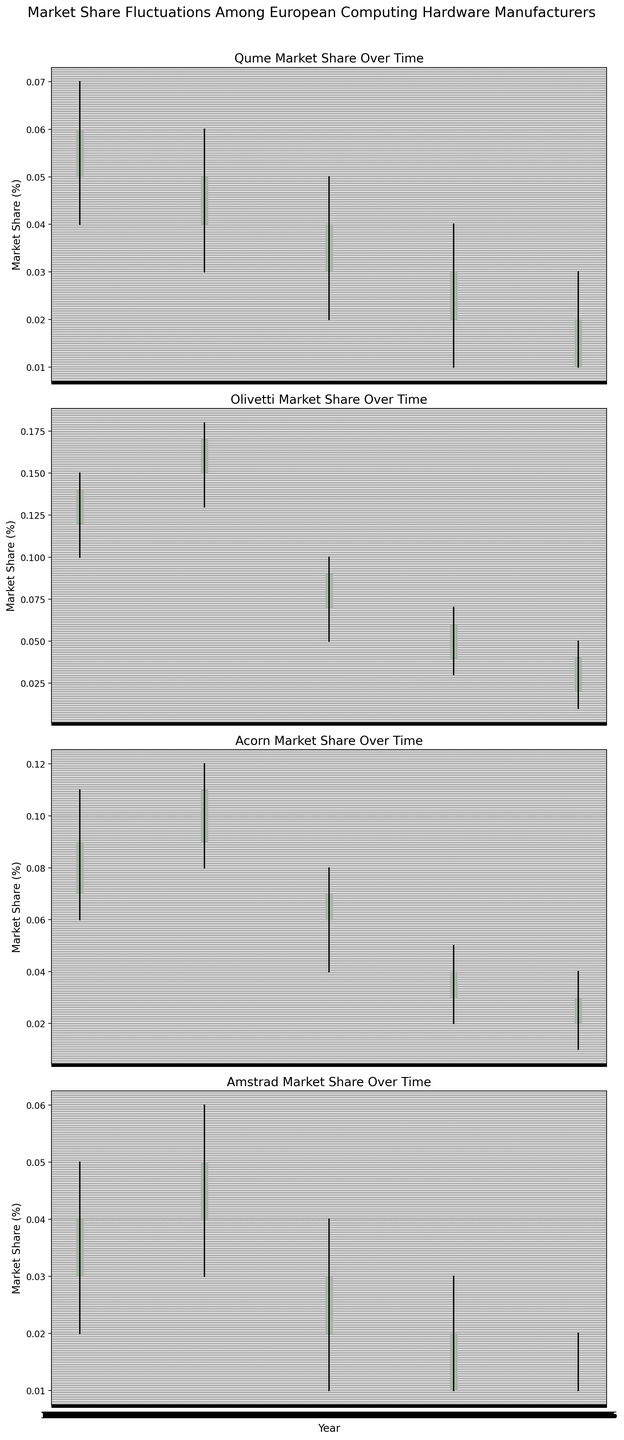Which company showed the highest market share in 1993? Look at the year 1993 across all subplots; observe Olivetti's candlestick, which has the highest market share value.
Answer: Olivetti What was the general trend for Amstrad's market share from 1983 to 2023? Observe the downward trend in the candlestick heights for Amstrad from 1983 to 2023, indicating a decline in market share over time.
Answer: Declining Which company had the smallest difference between its highest and lowest market share in 2023? For each company in 2023, calculate the differences between the high and low values: Qume (0.02), Olivetti (0.04), Acorn (0.03), Amstrad (0.01). Amstrad has the smallest difference.
Answer: Amstrad How many companies had a closing market share in 2003 that was higher than the opening market share? Compare the open and close values for each company in 2003. Olivetti (0.09 > 0.07), Acorn (0.07 > 0.06), so only these two companies have higher closing values.
Answer: 2 By what percentage did Olivetti's market share decrease from 1993 to 2003? Calculate the percentage decrease from 1993 to 2003 for Olivetti using the closing values: ((0.17 - 0.09) / 0.17) * 100%.
Answer: 47.06% Which year showed the largest market share fluctuation for Acorn? Calculate the difference between high and low values for Acorn each year: 1983 (0.05), 1993 (0.04), 2003 (0.04), 2013 (0.03), 2023 (0.03). The year 1983 has the largest fluctuation.
Answer: 1983 Compare the market share of Qume and Amstrad in 1983. Which had a higher closing value? In 1983, Qume's closing value is 0.06, and Amstrad's closing value is 0.04. Therefore, Qume had a higher closing value.
Answer: Qume How did the market share of Qume change from 1983 to 1993? Compare Qume's opening and closing values between these years: In 1983, Qume's values were 0.05 (open) and 0.06 (close) while in 1993 they were 0.04 (open) and 0.05 (close). The closed value decreased from 0.06 to 0.05.
Answer: Decreased What was the closing market share for Acorn in 2013 and how did it rank compared to other companies in the same year? Look at the closing values in 2013: Qume (0.03), Olivetti (0.06), Acorn (0.04), and Amstrad (0.02). Rank them to see Acorn has the second highest closing value.
Answer: Second highest Which company experienced the most consistent market share, indicated by the smallest range between high and low values across all years? Calculate the range (high - low) for each company across all years and average them: Qume (0.02), Olivetti (0.08), Acorn (0.04), Amstrad (0.03). Qume has the smallest average range indicating the most consistency.
Answer: Qume 